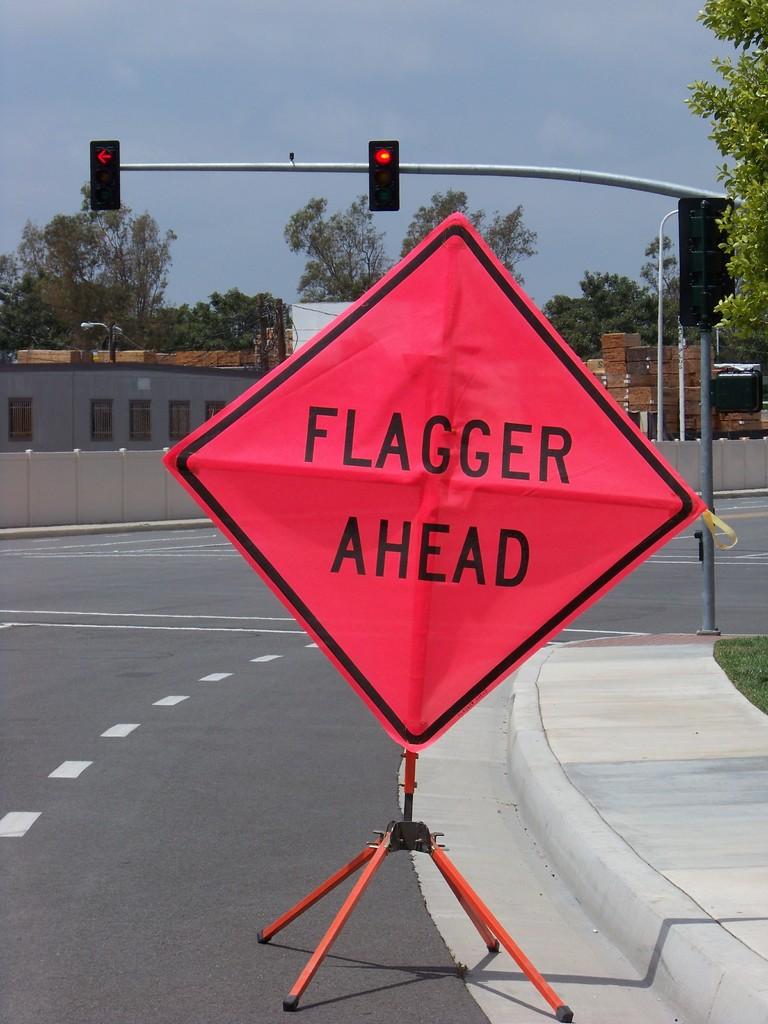What's up ahead?
Keep it short and to the point. Flagger. 